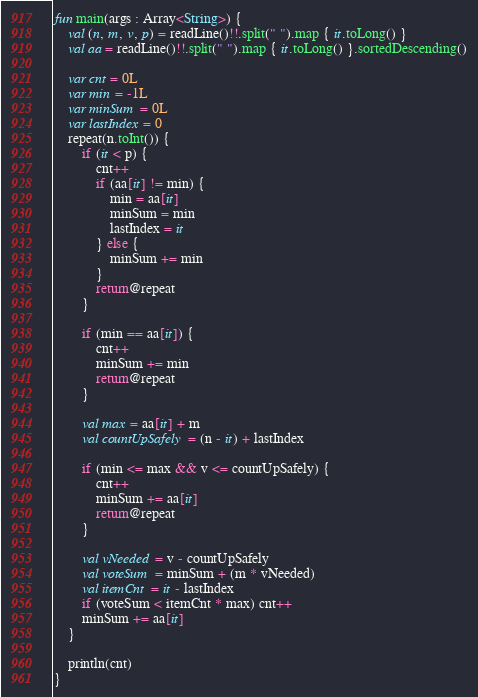Convert code to text. <code><loc_0><loc_0><loc_500><loc_500><_Kotlin_>fun main(args : Array<String>) {
    val (n, m, v, p) = readLine()!!.split(" ").map { it.toLong() }
    val aa = readLine()!!.split(" ").map { it.toLong() }.sortedDescending()

    var cnt = 0L
    var min = -1L
    var minSum = 0L
    var lastIndex = 0
    repeat(n.toInt()) {
        if (it < p) {
            cnt++
            if (aa[it] != min) {
                min = aa[it]
                minSum = min
                lastIndex = it
            } else {
                minSum += min
            }
            return@repeat
        }

        if (min == aa[it]) {
            cnt++
            minSum += min
            return@repeat
        }

        val max = aa[it] + m
        val countUpSafely = (n - it) + lastIndex

        if (min <= max && v <= countUpSafely) {
            cnt++
            minSum += aa[it]
            return@repeat
        }

        val vNeeded = v - countUpSafely
        val voteSum = minSum + (m * vNeeded)
        val itemCnt = it - lastIndex
        if (voteSum < itemCnt * max) cnt++
        minSum += aa[it]
    }

    println(cnt)
}</code> 